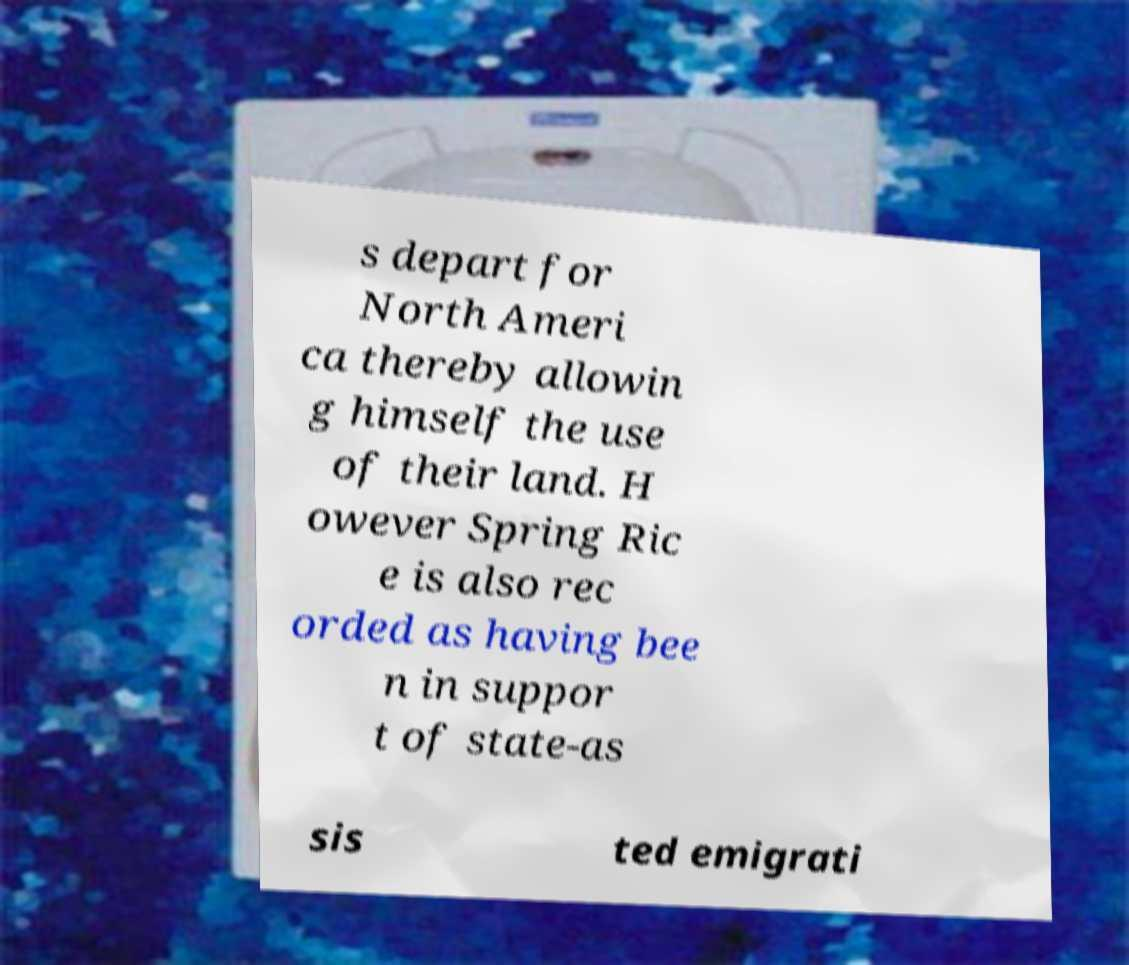Could you extract and type out the text from this image? s depart for North Ameri ca thereby allowin g himself the use of their land. H owever Spring Ric e is also rec orded as having bee n in suppor t of state-as sis ted emigrati 